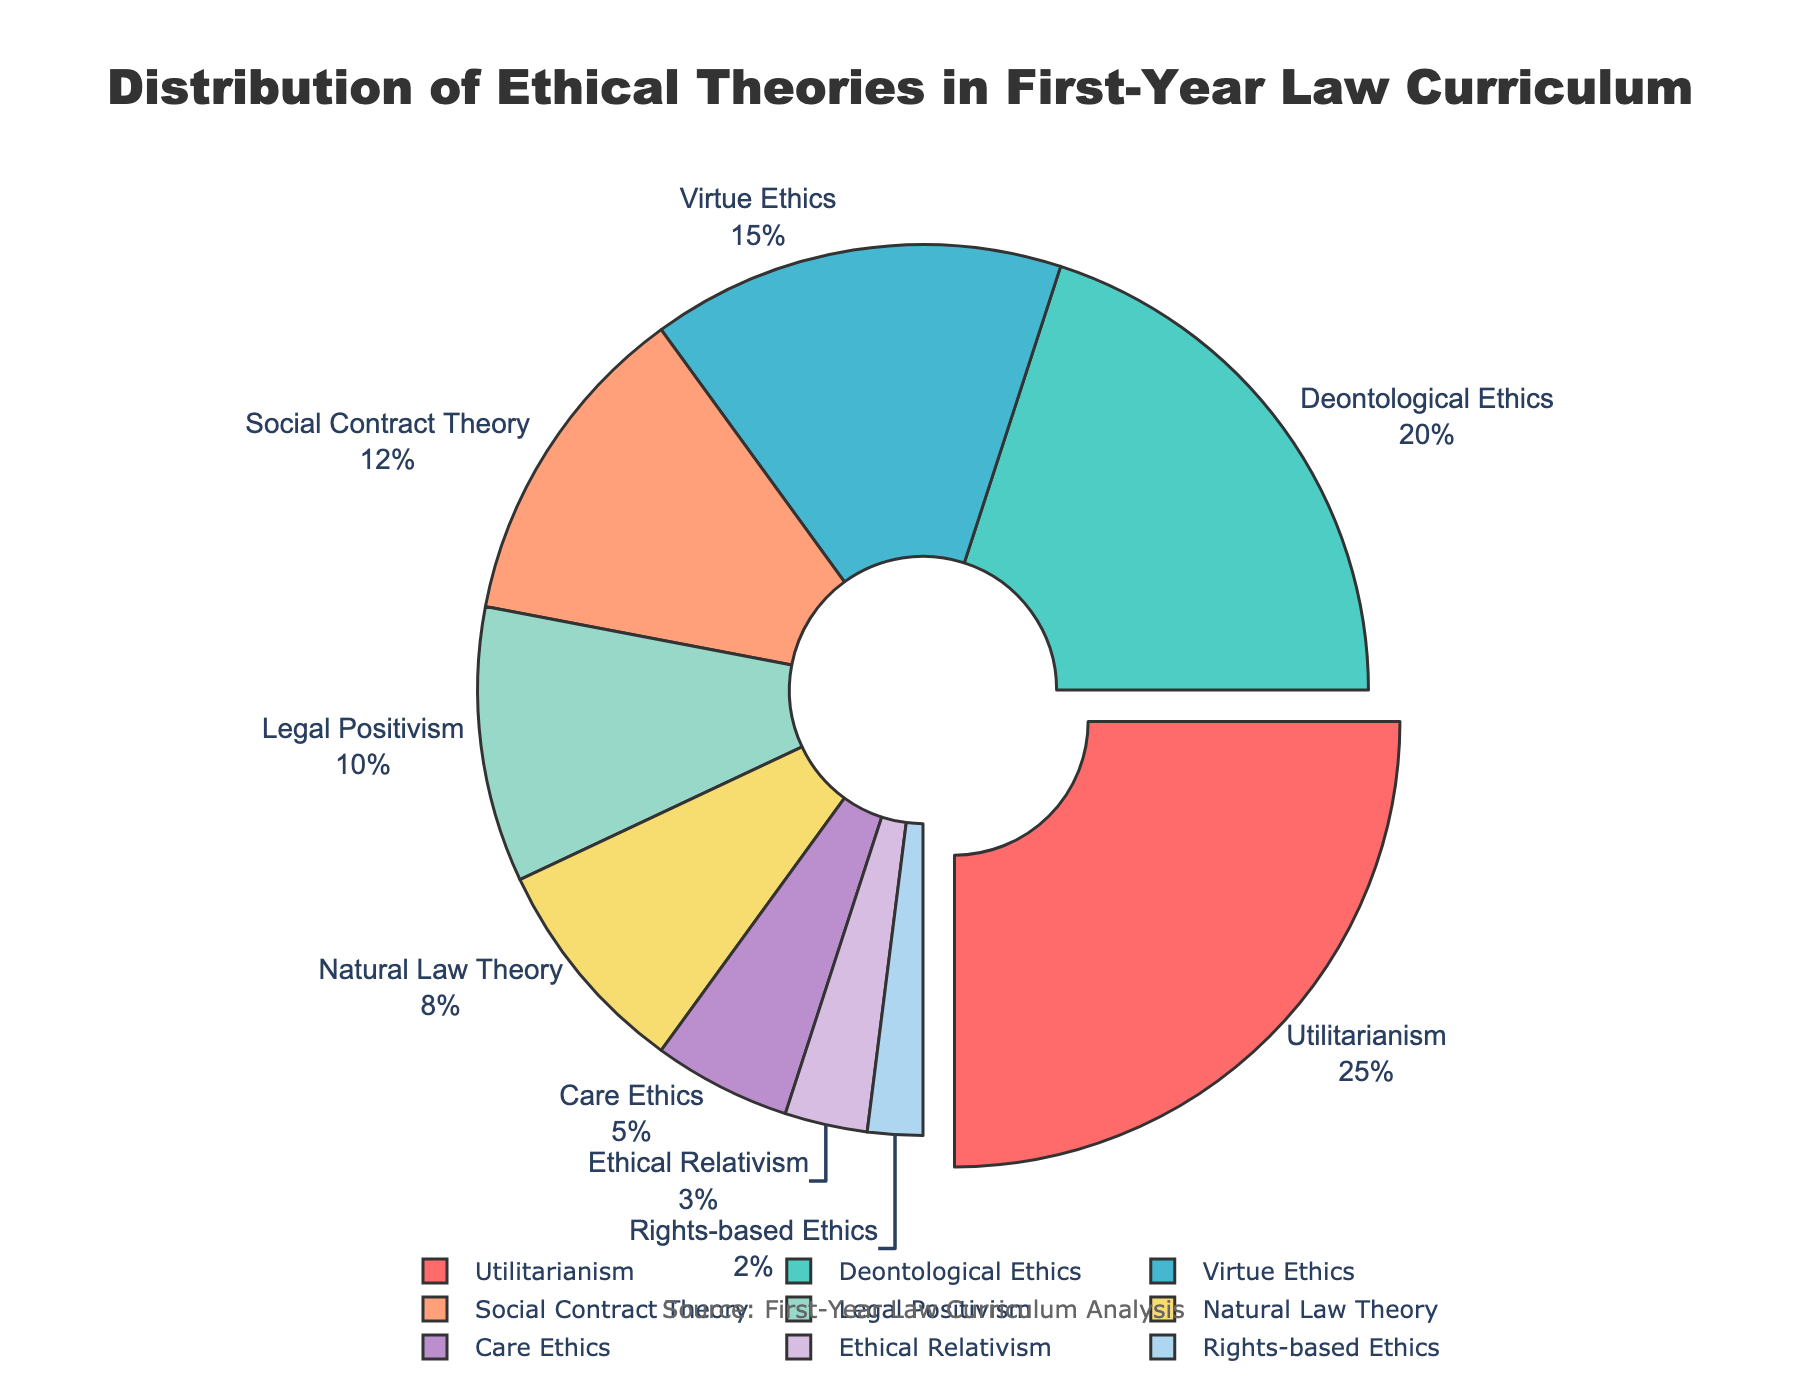What percentage of the curriculum is devoted to Utilitarianism and Deontological Ethics combined? To find the combined percentage, add the values for Utilitarianism (25%) and Deontological Ethics (20%). 25 + 20 = 45.
Answer: 45% Which ethical theory has the smallest portion of the curriculum? The smallest portion of the curriculum is the theory with the lowest percentage. According to the figure, Rights-based Ethics has the smallest portion at 2%.
Answer: Rights-based Ethics Is the percentage allocated to Virtue Ethics greater than that of Legal Positivism and Natural Law Theory combined? First calculate the combined percentage of Legal Positivism (10%) and Natural Law Theory (8%). This is 10 + 8 = 18. Compare this to Virtue Ethics, which is 15%. Since 15 is not greater than 18, the answer is no.
Answer: No What is the difference in percentage between the highest and lowest allocated ethical theories? The highest percentage is Utilitarianism at 25%, and the lowest is Rights-based Ethics at 2%. The difference is 25 - 2 = 23.
Answer: 23 Which section of the pie chart is pulled out from the center and why? The section for Utilitarianism is pulled out from the center because it represents the largest percentage (25%) of the curriculum.
Answer: Utilitarianism How much more of the curriculum is dedicated to Care Ethics compared to Ethical Relativism? Care Ethics has 5% and Ethical Relativism has 3%. The difference between these is 5 - 3 = 2.
Answer: 2% What is the percentage difference between Deontological Ethics and Social Contract Theory? Deontological Ethics has 20% and Social Contract Theory has 12%. The difference is 20 - 12 = 8.
Answer: 8 Which ethical theories together make up more than half of the curriculum? Add percentages in the order presented until you exceed 50%. Utilitarianism (25%) + Deontological Ethics (20%) = 45%, adding Virtue Ethics (15%) brings the total to 60%. So, those are the three theories.
Answer: Utilitarianism, Deontological Ethics, Virtue Ethics 